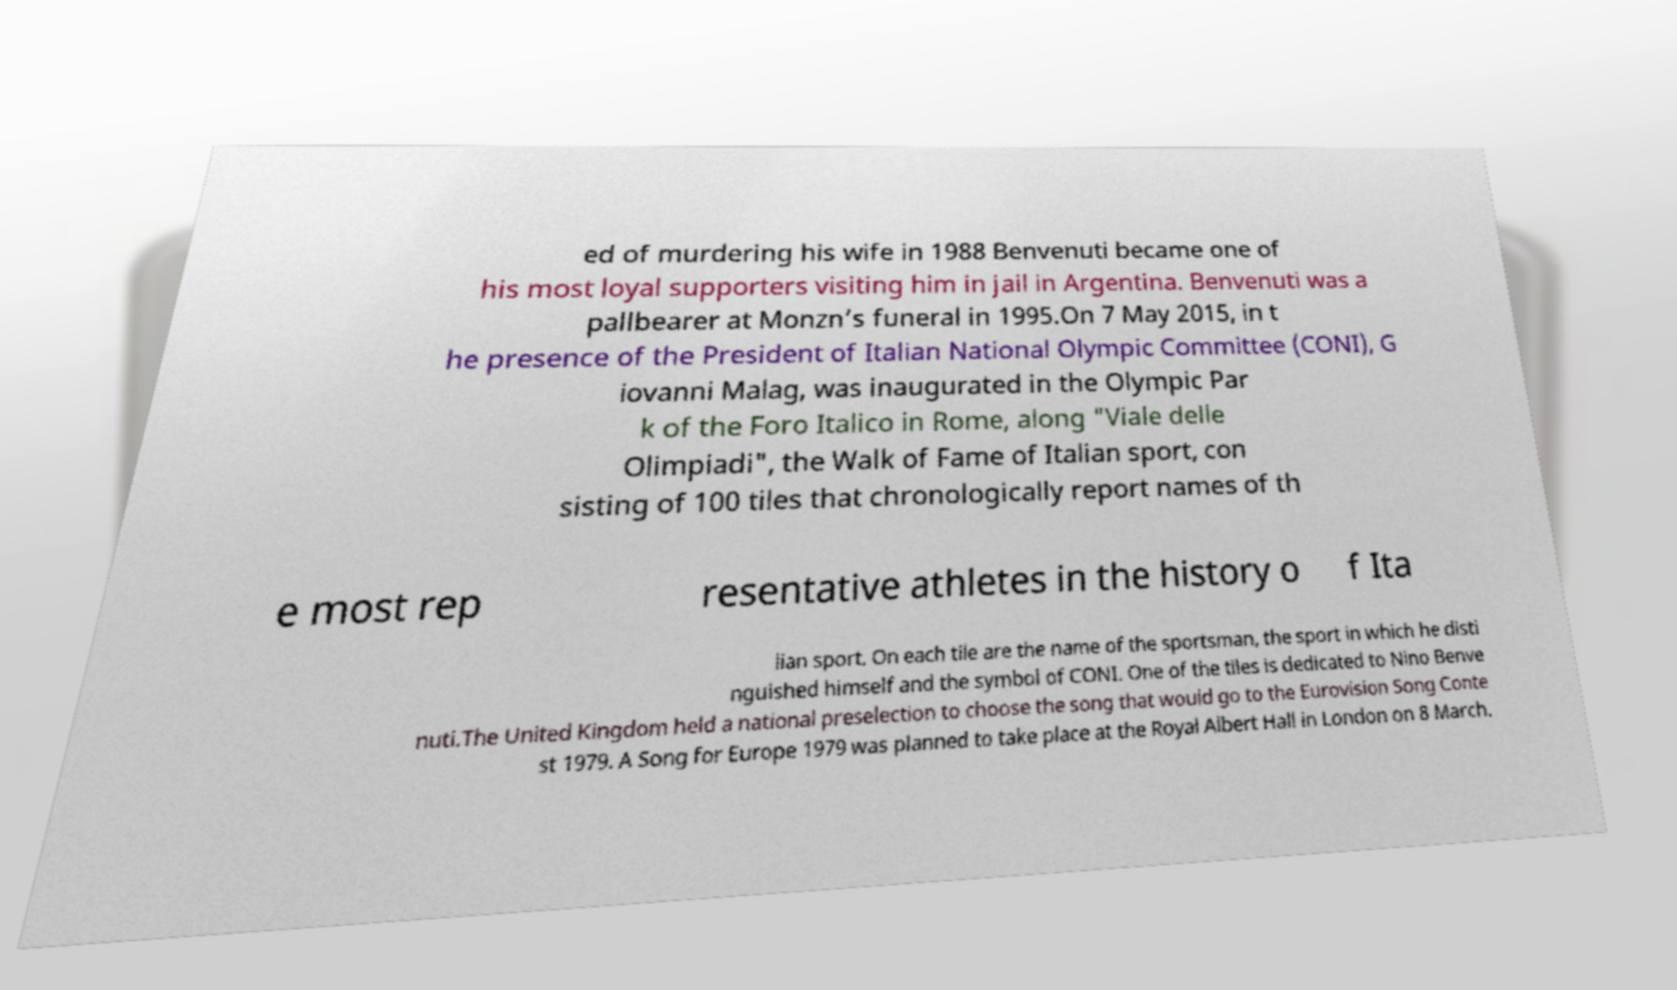Could you extract and type out the text from this image? ed of murdering his wife in 1988 Benvenuti became one of his most loyal supporters visiting him in jail in Argentina. Benvenuti was a pallbearer at Monzn’s funeral in 1995.On 7 May 2015, in t he presence of the President of Italian National Olympic Committee (CONI), G iovanni Malag, was inaugurated in the Olympic Par k of the Foro Italico in Rome, along "Viale delle Olimpiadi", the Walk of Fame of Italian sport, con sisting of 100 tiles that chronologically report names of th e most rep resentative athletes in the history o f Ita lian sport. On each tile are the name of the sportsman, the sport in which he disti nguished himself and the symbol of CONI. One of the tiles is dedicated to Nino Benve nuti.The United Kingdom held a national preselection to choose the song that would go to the Eurovision Song Conte st 1979. A Song for Europe 1979 was planned to take place at the Royal Albert Hall in London on 8 March. 